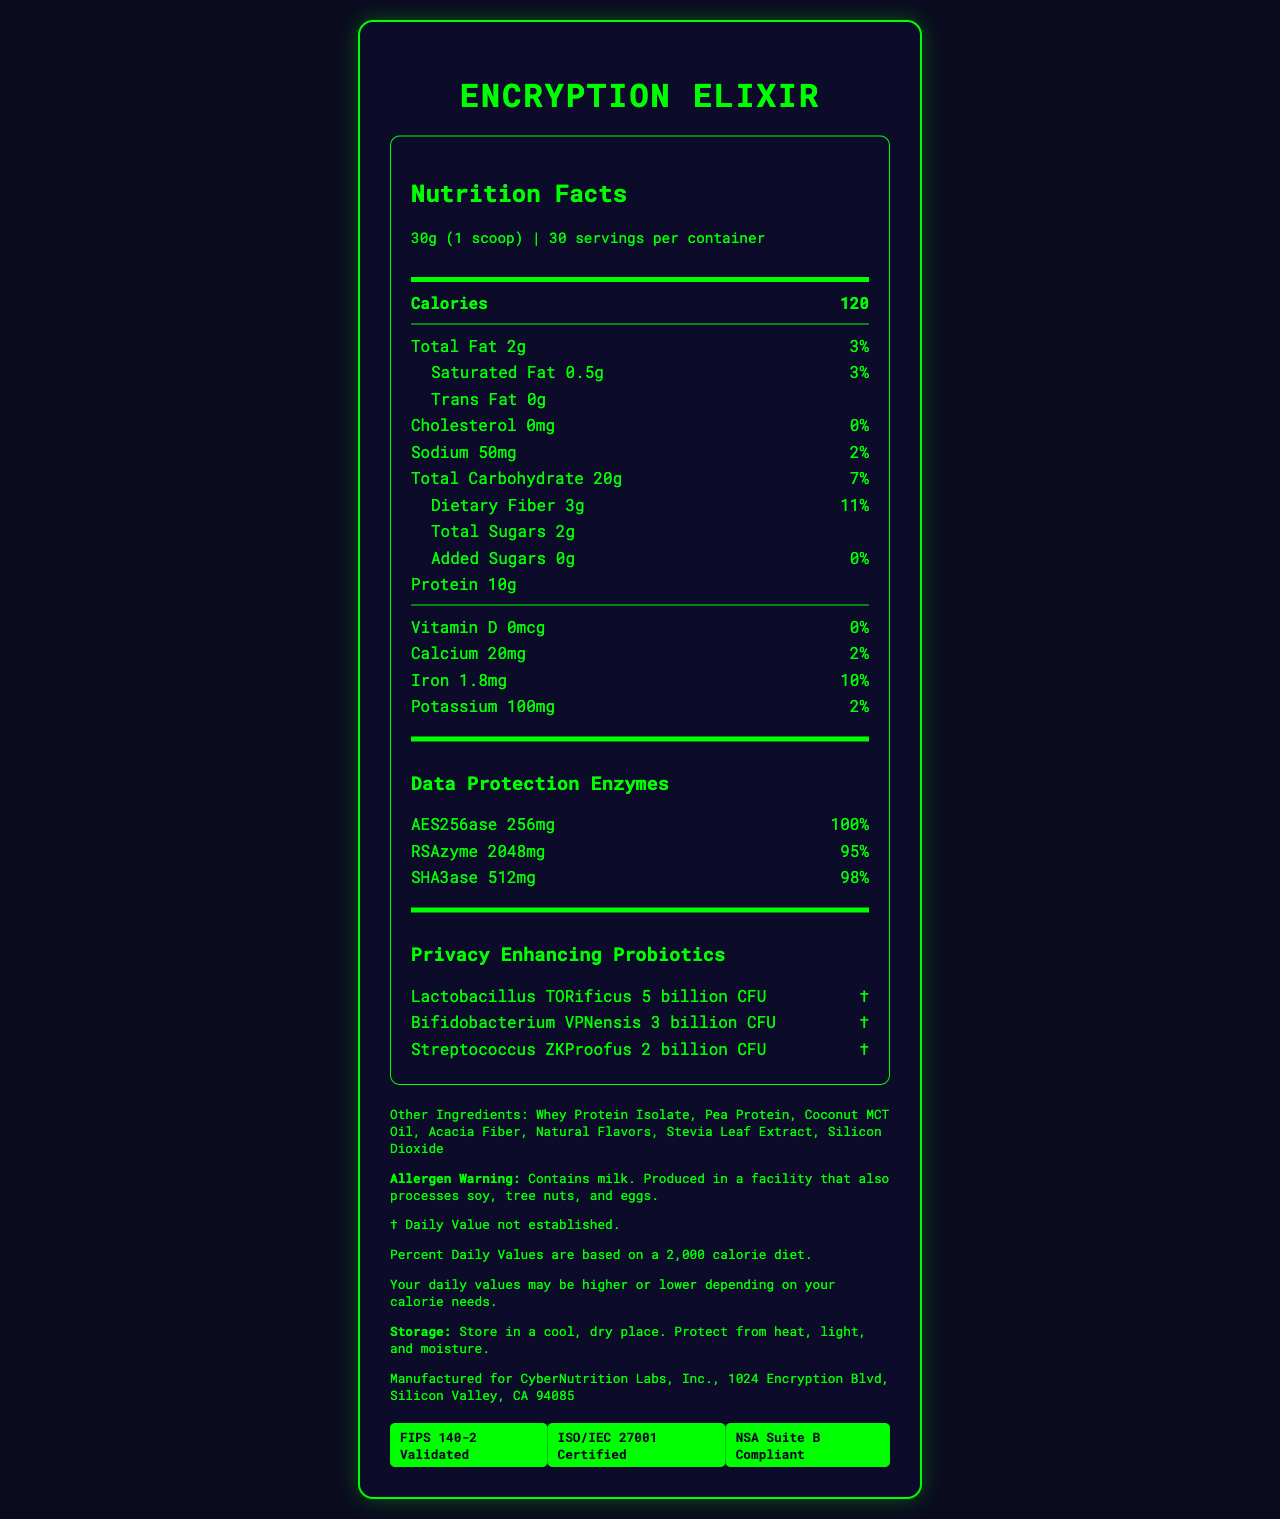what is the serving size of the Encryption Elixir? The serving size is clearly listed at the top of the Nutrition Facts section of the document.
Answer: 30g (1 scoop) how many servings are in one container? The document states that there are 30 servings per container.
Answer: 30 how many calories are in one serving? The calorie count is specified in the Nutrition Facts section, next to the serving size.
Answer: 120 what is the daily value percentage of total fat? The daily value percentage of total fat is provided next to the total fat amount (2g).
Answer: 3% how much dietary fiber is in one serving? The amount of dietary fiber is listed as 3g in the document.
Answer: 3g what certifications does Encryption Elixir have? A. FIPS 140-2 Validated B. ISO/IEC 27001 Certified C. NSA Suite B Compliant D. All of the above All these certifications are listed in the Certifications section of the document.
Answer: D. All of the above what allergen is mentioned in the warning? A. Soy B. Tree nuts C. Egg D. Milk The allergen warning specifically mentions "Contains milk."
Answer: D. Milk what are the other ingredients in Encryption Elixir? The "Other Ingredients" section lists all these components.
Answer: Whey Protein Isolate, Pea Protein, Coconut MCT Oil, Acacia Fiber, Natural Flavors, Stevia Leaf Extract, Silicon Dioxide is there any cholesterol in the Encryption Elixir? The amount of cholesterol is listed as 0mg with a 0% daily value.
Answer: No does the document provide enough information to determine the exact manufacturing process? The document provides manufacturer information but does not detail the manufacturing process itself.
Answer: No how much vitamin D does a serving provide? The document shows 0mcg of vitamin D with a 0% daily value.
Answer: 0mcg how would you describe the Encryption Elixir based on the document? The document provides the product name, nutritional information, custom ingredients for cybersecurity themes, allergen warnings, certifications, and storage instructions.
Answer: A nutrient-rich smoothie powder with data protection and privacy-enhancing components, containing various vitamins and minerals. It is certified for security standards and contains specific allergens in a serving size of 30g. how many billion CFU of Lactobacillus TORificus are in one serving? The document lists 5 billion CFU for Lactobacillus TORificus under the Privacy Enhancing Probiotics section.
Answer: 5 billion CFU what is the address of CyberNutrition Labs, Inc.? The manufacturer information section provides this address.
Answer: 1024 Encryption Blvd, Silicon Valley, CA 94085 what is the daily value percentage of added sugars? The daily value for added sugars is clearly stated as 0% in the document.
Answer: 0% 